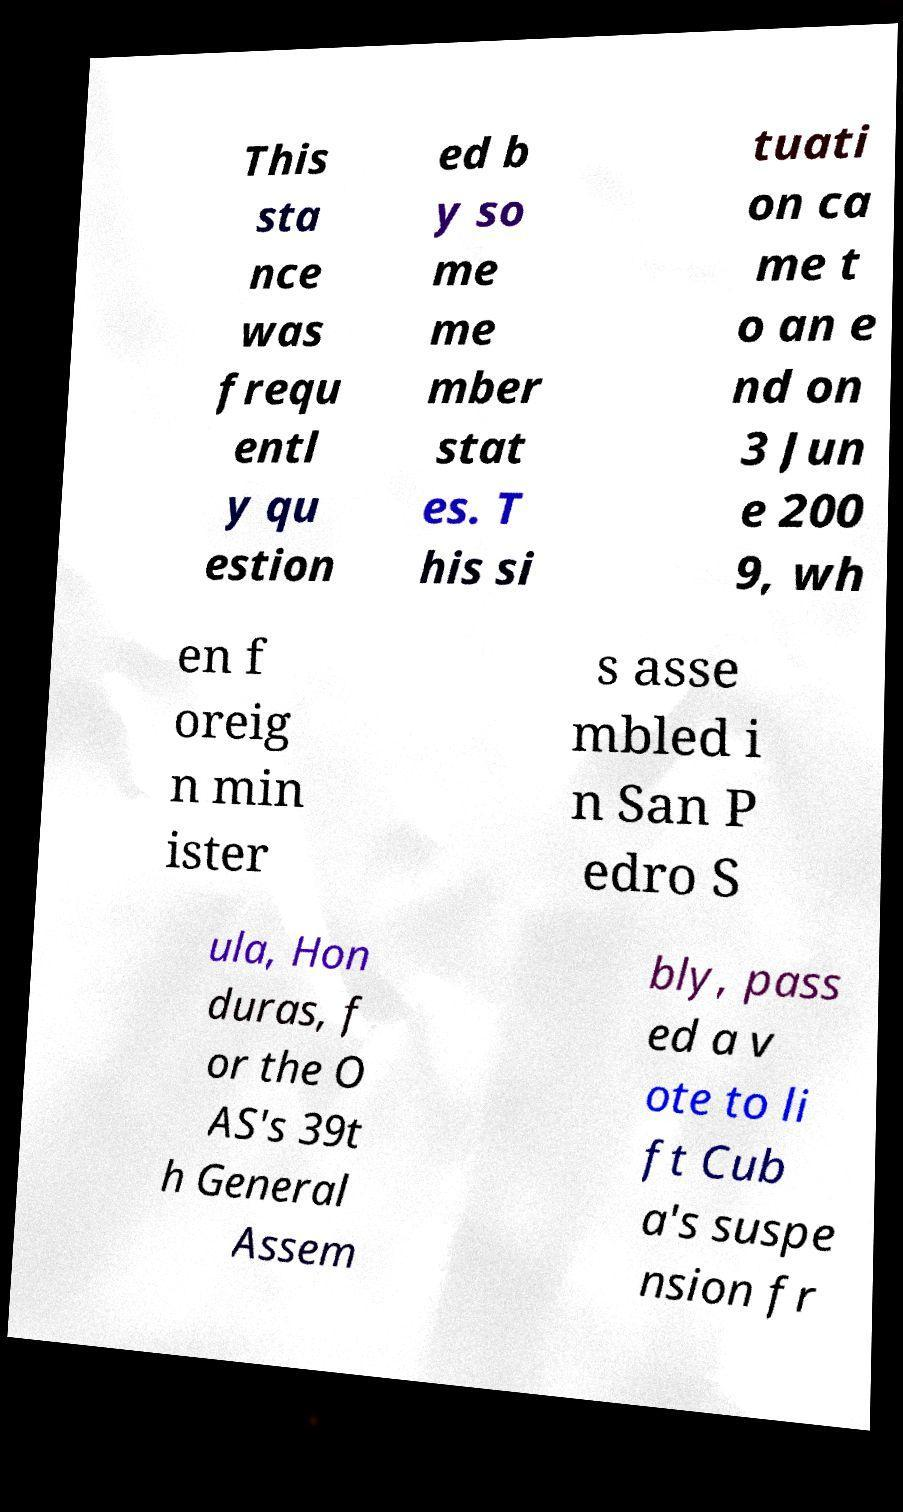Please read and relay the text visible in this image. What does it say? This sta nce was frequ entl y qu estion ed b y so me me mber stat es. T his si tuati on ca me t o an e nd on 3 Jun e 200 9, wh en f oreig n min ister s asse mbled i n San P edro S ula, Hon duras, f or the O AS's 39t h General Assem bly, pass ed a v ote to li ft Cub a's suspe nsion fr 